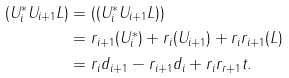<formula> <loc_0><loc_0><loc_500><loc_500>( U _ { i } ^ { * } U _ { i + 1 } L ) & = ( ( U _ { i } ^ { * } U _ { i + 1 } L ) ) \\ & = r _ { i + 1 } ( U _ { i } ^ { * } ) + r _ { i } ( U _ { i + 1 } ) + r _ { i } r _ { i + 1 } ( L ) \\ & = r _ { i } d _ { i + 1 } - r _ { i + 1 } d _ { i } + r _ { i } r _ { r + 1 } t .</formula> 